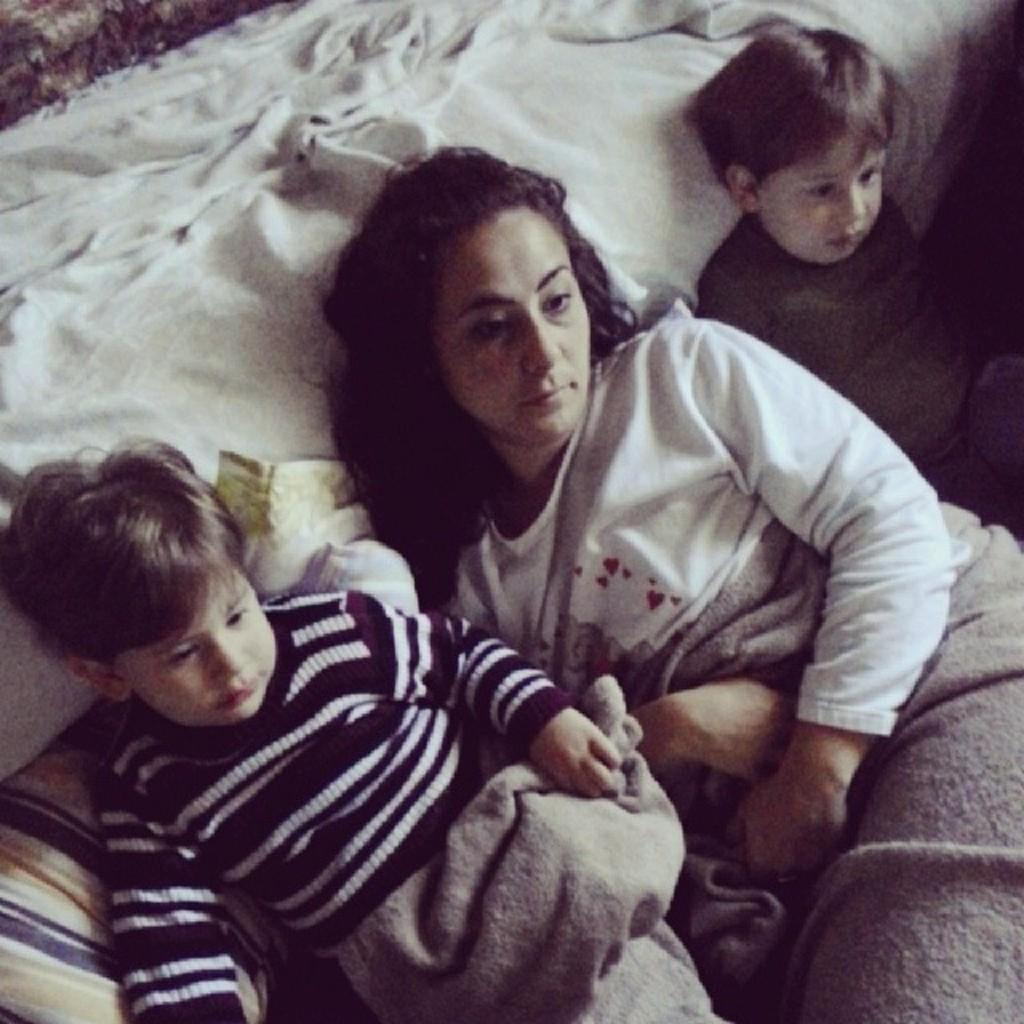What is the main object in the picture? There is a bed in the picture. What is happening on the bed? A woman and two kids are sleeping on the bed. What is covering the bottom part of the bed? There is a blanket at the bottom of the bed. What is placed on the left side of the bed? There is a pillow on the left side of the bed. What type of tree is growing in the middle of the bed? There is no tree growing in the middle of the bed; the image only shows a bed with a woman and two kids sleeping on it. 